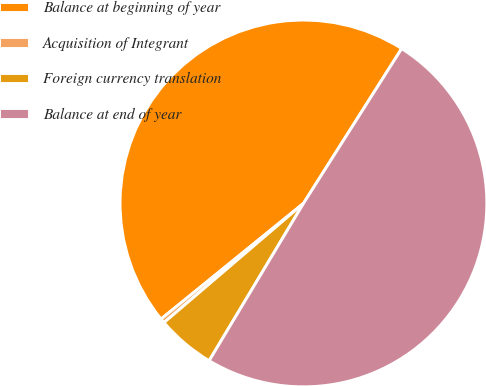<chart> <loc_0><loc_0><loc_500><loc_500><pie_chart><fcel>Balance at beginning of year<fcel>Acquisition of Integrant<fcel>Foreign currency translation<fcel>Balance at end of year<nl><fcel>44.85%<fcel>0.4%<fcel>5.15%<fcel>49.6%<nl></chart> 